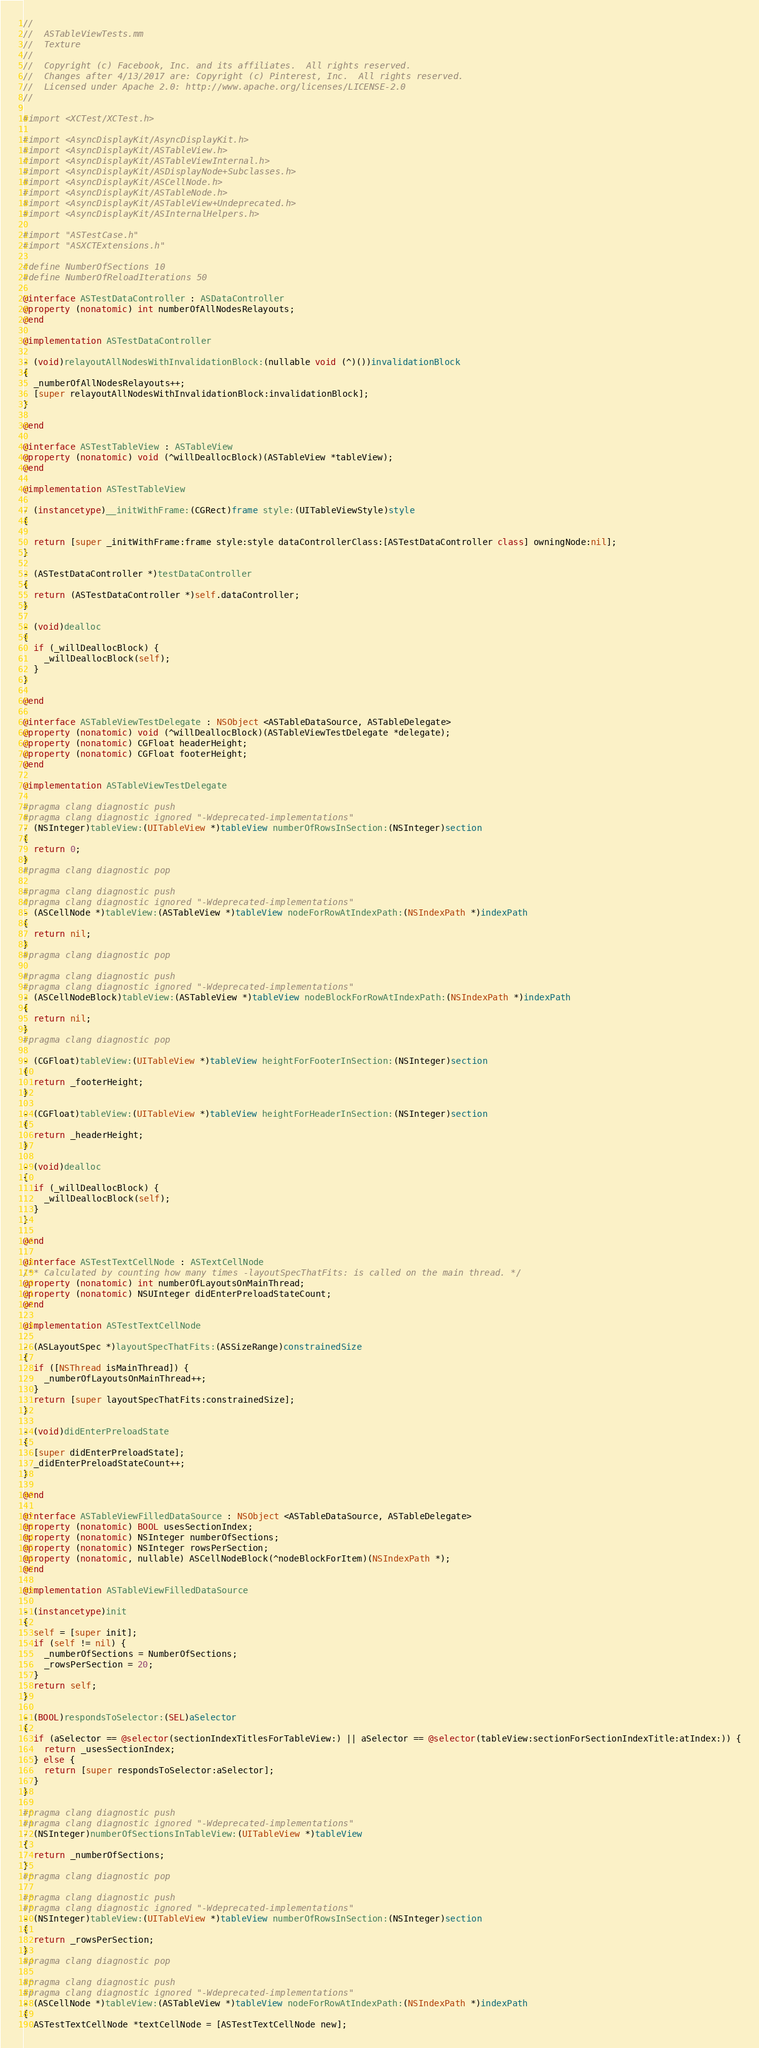<code> <loc_0><loc_0><loc_500><loc_500><_ObjectiveC_>//
//  ASTableViewTests.mm
//  Texture
//
//  Copyright (c) Facebook, Inc. and its affiliates.  All rights reserved.
//  Changes after 4/13/2017 are: Copyright (c) Pinterest, Inc.  All rights reserved.
//  Licensed under Apache 2.0: http://www.apache.org/licenses/LICENSE-2.0
//

#import <XCTest/XCTest.h>

#import <AsyncDisplayKit/AsyncDisplayKit.h>
#import <AsyncDisplayKit/ASTableView.h>
#import <AsyncDisplayKit/ASTableViewInternal.h>
#import <AsyncDisplayKit/ASDisplayNode+Subclasses.h>
#import <AsyncDisplayKit/ASCellNode.h>
#import <AsyncDisplayKit/ASTableNode.h>
#import <AsyncDisplayKit/ASTableView+Undeprecated.h>
#import <AsyncDisplayKit/ASInternalHelpers.h>

#import "ASTestCase.h"
#import "ASXCTExtensions.h"

#define NumberOfSections 10
#define NumberOfReloadIterations 50

@interface ASTestDataController : ASDataController
@property (nonatomic) int numberOfAllNodesRelayouts;
@end

@implementation ASTestDataController

- (void)relayoutAllNodesWithInvalidationBlock:(nullable void (^)())invalidationBlock
{
  _numberOfAllNodesRelayouts++;
  [super relayoutAllNodesWithInvalidationBlock:invalidationBlock];
}

@end

@interface ASTestTableView : ASTableView
@property (nonatomic) void (^willDeallocBlock)(ASTableView *tableView);
@end

@implementation ASTestTableView

- (instancetype)__initWithFrame:(CGRect)frame style:(UITableViewStyle)style
{
  
  return [super _initWithFrame:frame style:style dataControllerClass:[ASTestDataController class] owningNode:nil];
}

- (ASTestDataController *)testDataController
{
  return (ASTestDataController *)self.dataController;
}

- (void)dealloc
{
  if (_willDeallocBlock) {
    _willDeallocBlock(self);
  }
}

@end

@interface ASTableViewTestDelegate : NSObject <ASTableDataSource, ASTableDelegate>
@property (nonatomic) void (^willDeallocBlock)(ASTableViewTestDelegate *delegate);
@property (nonatomic) CGFloat headerHeight;
@property (nonatomic) CGFloat footerHeight;
@end

@implementation ASTableViewTestDelegate

#pragma clang diagnostic push
#pragma clang diagnostic ignored "-Wdeprecated-implementations"
- (NSInteger)tableView:(UITableView *)tableView numberOfRowsInSection:(NSInteger)section
{
  return 0;
}
#pragma clang diagnostic pop

#pragma clang diagnostic push
#pragma clang diagnostic ignored "-Wdeprecated-implementations"
- (ASCellNode *)tableView:(ASTableView *)tableView nodeForRowAtIndexPath:(NSIndexPath *)indexPath
{
  return nil;
}
#pragma clang diagnostic pop

#pragma clang diagnostic push
#pragma clang diagnostic ignored "-Wdeprecated-implementations"
- (ASCellNodeBlock)tableView:(ASTableView *)tableView nodeBlockForRowAtIndexPath:(NSIndexPath *)indexPath
{
  return nil;
}
#pragma clang diagnostic pop

- (CGFloat)tableView:(UITableView *)tableView heightForFooterInSection:(NSInteger)section
{
  return _footerHeight;
}

- (CGFloat)tableView:(UITableView *)tableView heightForHeaderInSection:(NSInteger)section
{
  return _headerHeight;
}

- (void)dealloc
{
  if (_willDeallocBlock) {
    _willDeallocBlock(self);
  }
}

@end

@interface ASTestTextCellNode : ASTextCellNode
/** Calculated by counting how many times -layoutSpecThatFits: is called on the main thread. */
@property (nonatomic) int numberOfLayoutsOnMainThread;
@property (nonatomic) NSUInteger didEnterPreloadStateCount;
@end

@implementation ASTestTextCellNode

- (ASLayoutSpec *)layoutSpecThatFits:(ASSizeRange)constrainedSize
{
  if ([NSThread isMainThread]) {
    _numberOfLayoutsOnMainThread++;
  }
  return [super layoutSpecThatFits:constrainedSize];
}

- (void)didEnterPreloadState
{
  [super didEnterPreloadState];
  _didEnterPreloadStateCount++;
}

@end

@interface ASTableViewFilledDataSource : NSObject <ASTableDataSource, ASTableDelegate>
@property (nonatomic) BOOL usesSectionIndex;
@property (nonatomic) NSInteger numberOfSections;
@property (nonatomic) NSInteger rowsPerSection;
@property (nonatomic, nullable) ASCellNodeBlock(^nodeBlockForItem)(NSIndexPath *);
@end

@implementation ASTableViewFilledDataSource

- (instancetype)init
{
  self = [super init];
  if (self != nil) {
    _numberOfSections = NumberOfSections;
    _rowsPerSection = 20;
  }
  return self;
}

- (BOOL)respondsToSelector:(SEL)aSelector
{
  if (aSelector == @selector(sectionIndexTitlesForTableView:) || aSelector == @selector(tableView:sectionForSectionIndexTitle:atIndex:)) {
    return _usesSectionIndex;
  } else {
    return [super respondsToSelector:aSelector];
  }
}

#pragma clang diagnostic push
#pragma clang diagnostic ignored "-Wdeprecated-implementations"
- (NSInteger)numberOfSectionsInTableView:(UITableView *)tableView
{
  return _numberOfSections;
}
#pragma clang diagnostic pop

#pragma clang diagnostic push
#pragma clang diagnostic ignored "-Wdeprecated-implementations"
- (NSInteger)tableView:(UITableView *)tableView numberOfRowsInSection:(NSInteger)section
{
  return _rowsPerSection;
}
#pragma clang diagnostic pop

#pragma clang diagnostic push
#pragma clang diagnostic ignored "-Wdeprecated-implementations"
- (ASCellNode *)tableView:(ASTableView *)tableView nodeForRowAtIndexPath:(NSIndexPath *)indexPath
{
  ASTestTextCellNode *textCellNode = [ASTestTextCellNode new];</code> 